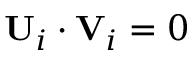<formula> <loc_0><loc_0><loc_500><loc_500>U _ { i } \cdot V _ { i } = 0</formula> 